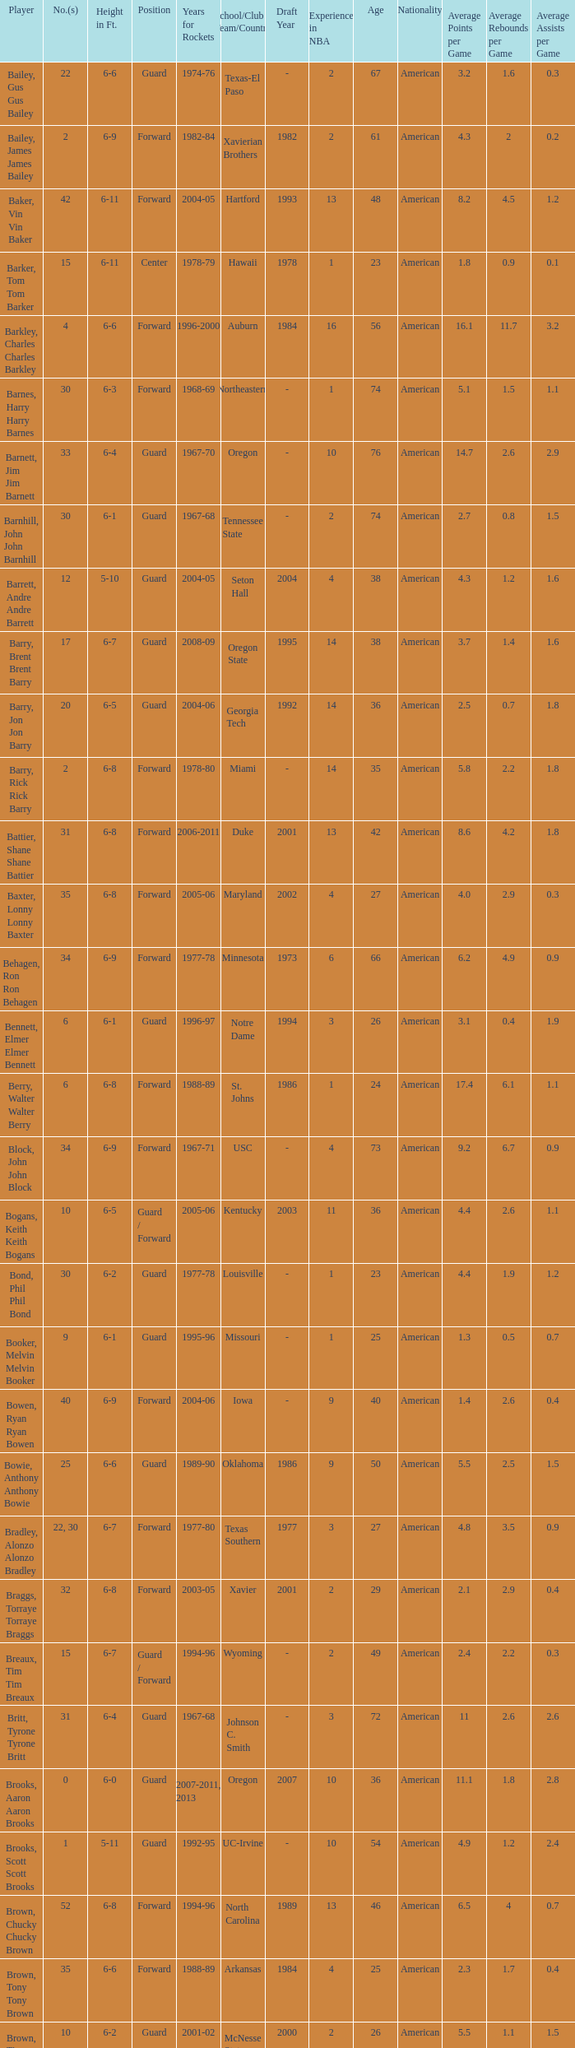What school did the forward whose number is 10 belong to? Arizona. 